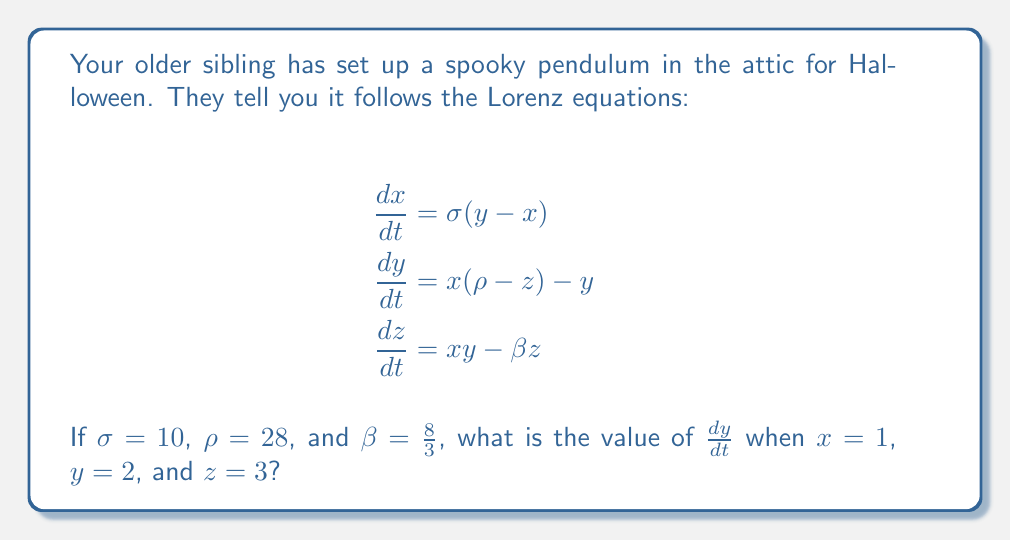Provide a solution to this math problem. Let's approach this step-by-step:

1) We're given the Lorenz equations, and we need to focus on the second equation:

   $$\frac{dy}{dt} = x(\rho-z) - y$$

2) We're also given the values:
   $x = 1$, $y = 2$, $z = 3$, and $\rho = 28$

3) Let's substitute these values into the equation:

   $$\frac{dy}{dt} = 1(28-3) - 2$$

4) First, let's calculate what's inside the parentheses:
   $28 - 3 = 25$

5) Now our equation looks like this:

   $$\frac{dy}{dt} = 1(25) - 2$$

6) Multiply:
   $$\frac{dy}{dt} = 25 - 2$$

7) Finally, subtract:
   $$\frac{dy}{dt} = 23$$

Therefore, when $x = 1$, $y = 2$, and $z = 3$, the value of $\frac{dy}{dt}$ is 23.
Answer: 23 